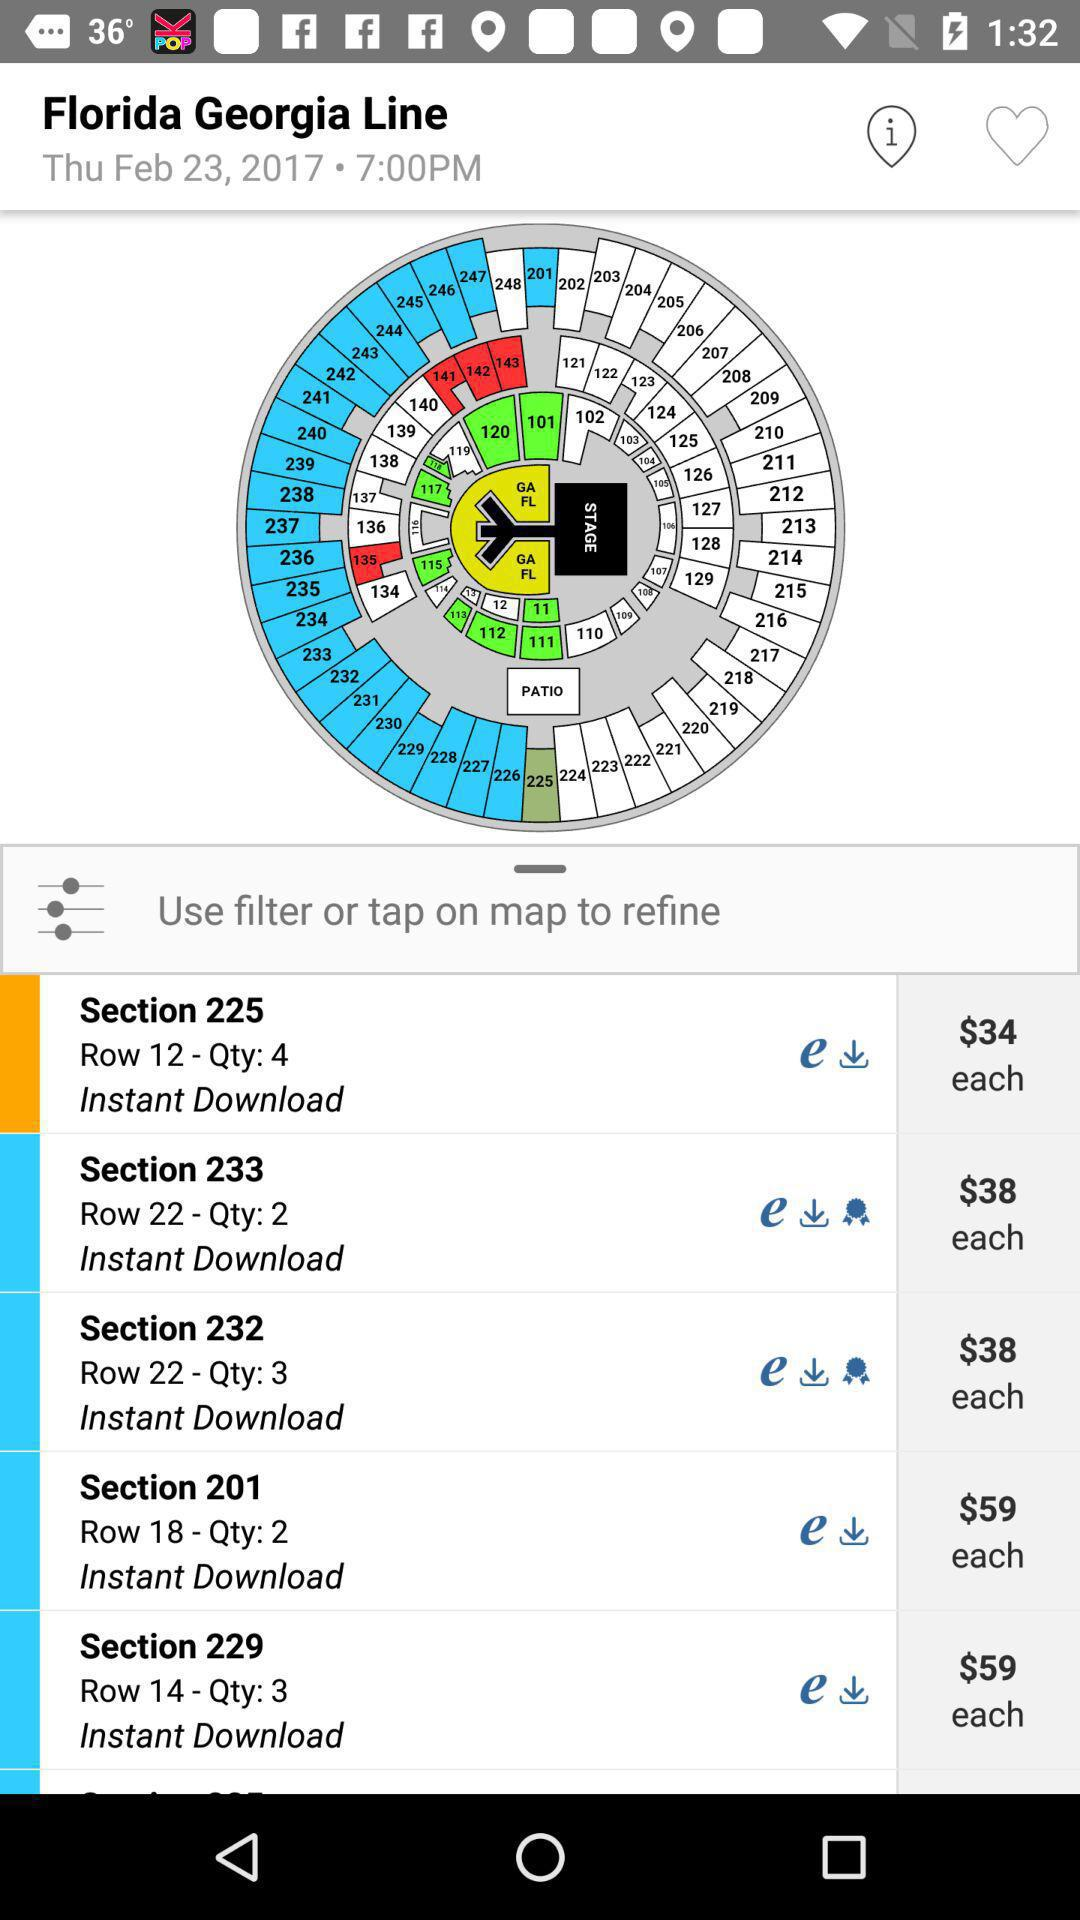What is the time? The time is 7:00 PM. 